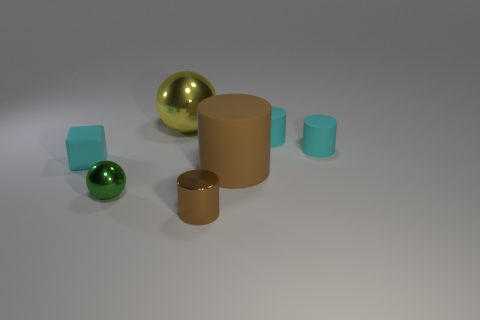Subtract all matte cylinders. How many cylinders are left? 1 Subtract all gray spheres. How many cyan cylinders are left? 2 Subtract all cyan cylinders. How many cylinders are left? 2 Subtract all cylinders. How many objects are left? 3 Subtract 1 cylinders. How many cylinders are left? 3 Add 2 yellow spheres. How many objects exist? 9 Subtract all cyan cylinders. Subtract all blue spheres. How many cylinders are left? 2 Subtract all big matte cylinders. Subtract all tiny metallic things. How many objects are left? 4 Add 6 big rubber objects. How many big rubber objects are left? 7 Add 6 large rubber things. How many large rubber things exist? 7 